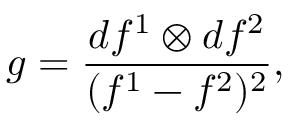<formula> <loc_0><loc_0><loc_500><loc_500>g = \frac { d f ^ { 1 } \otimes d f ^ { 2 } } { ( f ^ { 1 } - f ^ { 2 } ) ^ { 2 } } ,</formula> 